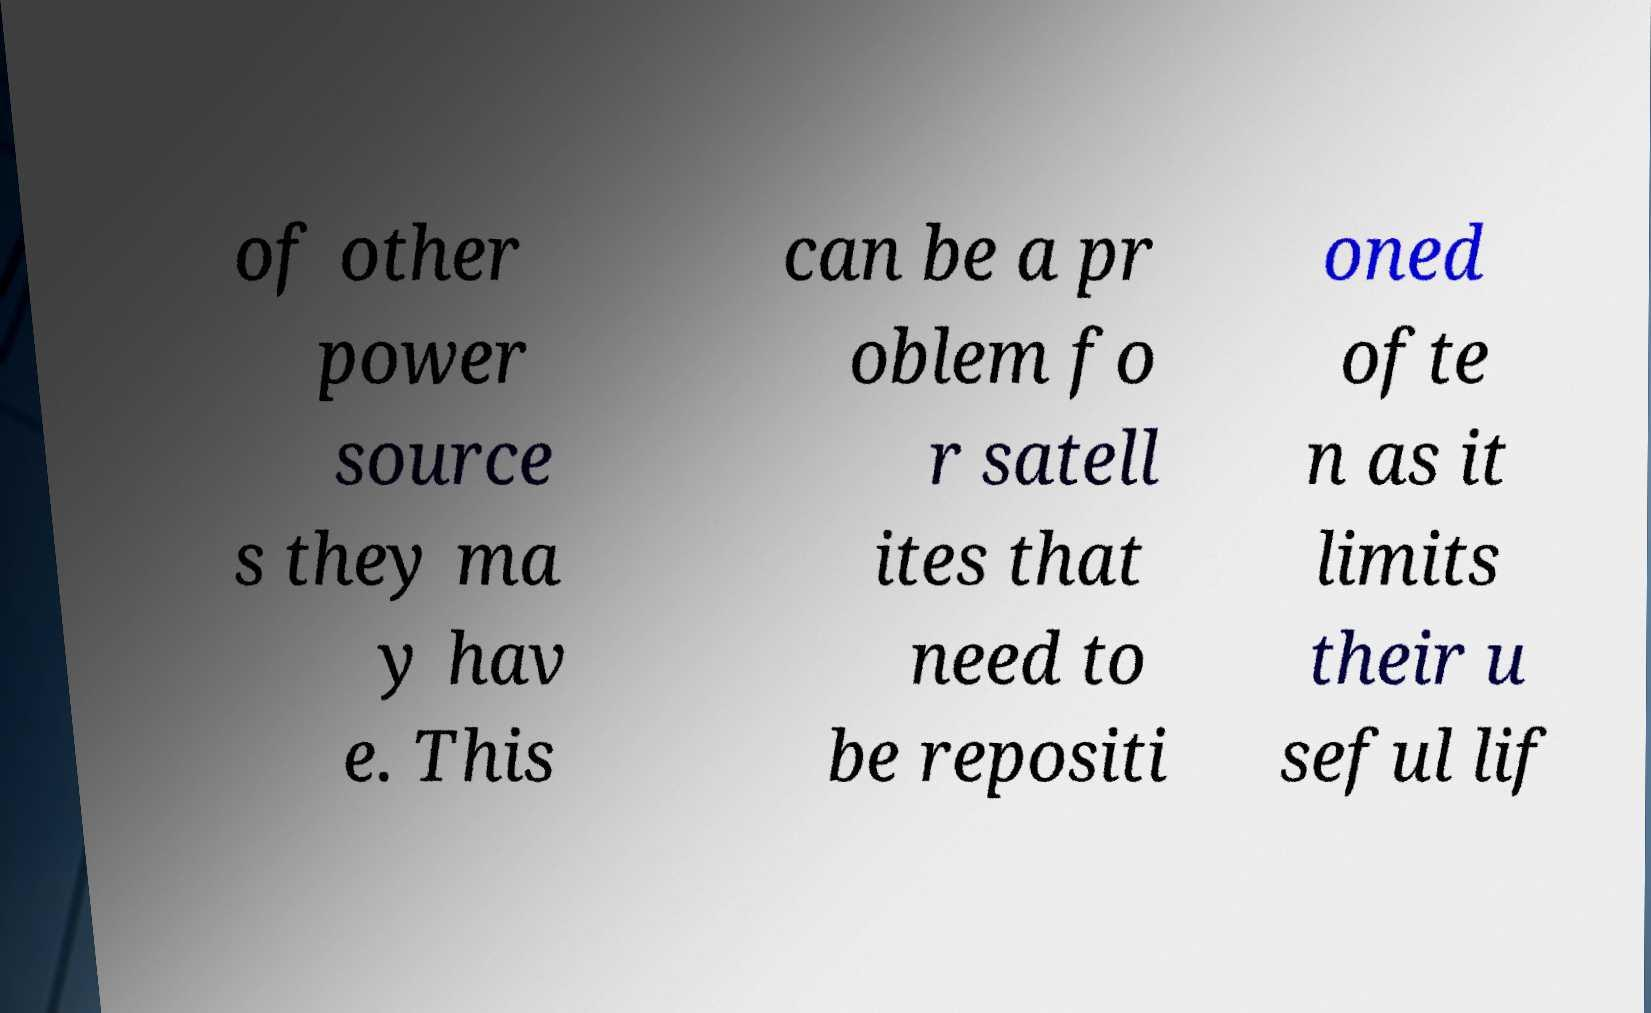There's text embedded in this image that I need extracted. Can you transcribe it verbatim? of other power source s they ma y hav e. This can be a pr oblem fo r satell ites that need to be repositi oned ofte n as it limits their u seful lif 